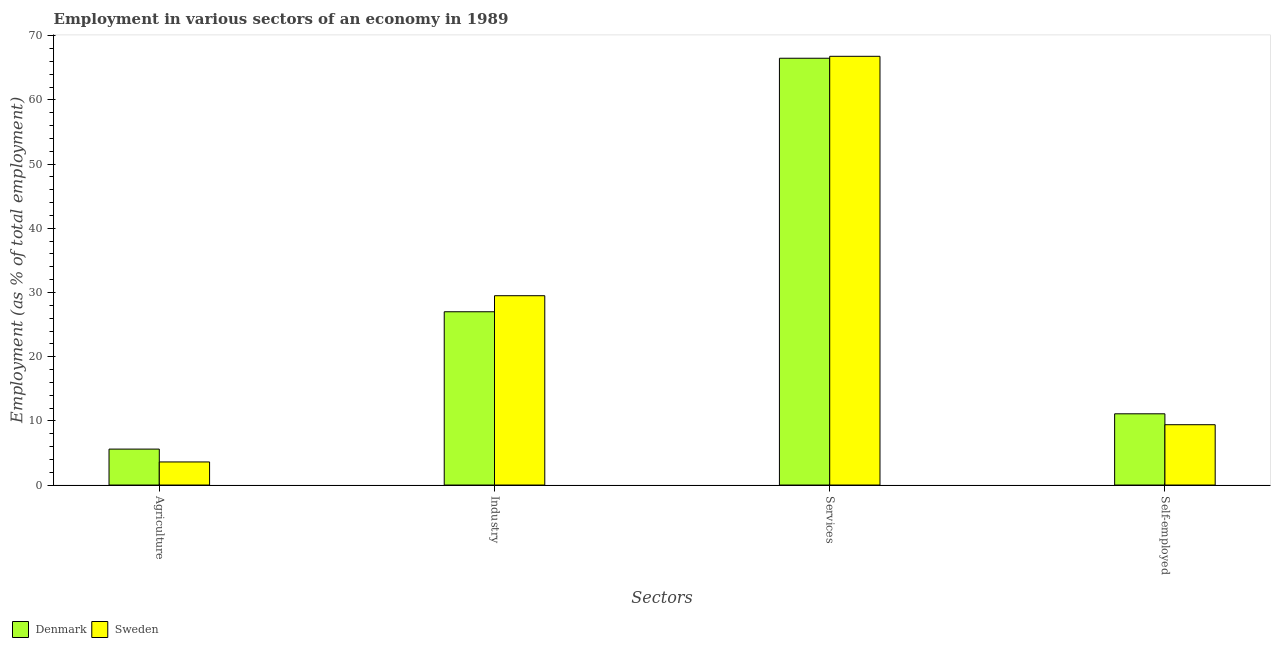Are the number of bars on each tick of the X-axis equal?
Make the answer very short. Yes. How many bars are there on the 3rd tick from the right?
Your answer should be very brief. 2. What is the label of the 2nd group of bars from the left?
Your answer should be very brief. Industry. What is the percentage of workers in services in Sweden?
Provide a succinct answer. 66.8. Across all countries, what is the maximum percentage of workers in industry?
Your answer should be compact. 29.5. In which country was the percentage of workers in industry maximum?
Your response must be concise. Sweden. What is the total percentage of workers in services in the graph?
Provide a short and direct response. 133.3. What is the difference between the percentage of workers in services in Sweden and that in Denmark?
Ensure brevity in your answer.  0.3. What is the difference between the percentage of workers in agriculture in Sweden and the percentage of workers in industry in Denmark?
Your answer should be compact. -23.4. What is the average percentage of workers in industry per country?
Give a very brief answer. 28.25. What is the difference between the percentage of workers in industry and percentage of workers in agriculture in Sweden?
Your answer should be very brief. 25.9. In how many countries, is the percentage of workers in services greater than 26 %?
Keep it short and to the point. 2. What is the ratio of the percentage of self employed workers in Denmark to that in Sweden?
Offer a very short reply. 1.18. What is the difference between the highest and the second highest percentage of self employed workers?
Provide a succinct answer. 1.7. What is the difference between the highest and the lowest percentage of workers in services?
Your response must be concise. 0.3. In how many countries, is the percentage of workers in agriculture greater than the average percentage of workers in agriculture taken over all countries?
Give a very brief answer. 1. Is it the case that in every country, the sum of the percentage of workers in agriculture and percentage of workers in industry is greater than the percentage of workers in services?
Your answer should be very brief. No. What is the difference between two consecutive major ticks on the Y-axis?
Your answer should be very brief. 10. Does the graph contain grids?
Offer a very short reply. No. What is the title of the graph?
Your answer should be very brief. Employment in various sectors of an economy in 1989. What is the label or title of the X-axis?
Ensure brevity in your answer.  Sectors. What is the label or title of the Y-axis?
Ensure brevity in your answer.  Employment (as % of total employment). What is the Employment (as % of total employment) of Denmark in Agriculture?
Your answer should be very brief. 5.6. What is the Employment (as % of total employment) of Sweden in Agriculture?
Offer a terse response. 3.6. What is the Employment (as % of total employment) of Sweden in Industry?
Offer a terse response. 29.5. What is the Employment (as % of total employment) of Denmark in Services?
Give a very brief answer. 66.5. What is the Employment (as % of total employment) of Sweden in Services?
Ensure brevity in your answer.  66.8. What is the Employment (as % of total employment) of Denmark in Self-employed?
Give a very brief answer. 11.1. What is the Employment (as % of total employment) in Sweden in Self-employed?
Your response must be concise. 9.4. Across all Sectors, what is the maximum Employment (as % of total employment) in Denmark?
Provide a succinct answer. 66.5. Across all Sectors, what is the maximum Employment (as % of total employment) in Sweden?
Ensure brevity in your answer.  66.8. Across all Sectors, what is the minimum Employment (as % of total employment) of Denmark?
Your answer should be compact. 5.6. Across all Sectors, what is the minimum Employment (as % of total employment) in Sweden?
Keep it short and to the point. 3.6. What is the total Employment (as % of total employment) in Denmark in the graph?
Offer a very short reply. 110.2. What is the total Employment (as % of total employment) of Sweden in the graph?
Ensure brevity in your answer.  109.3. What is the difference between the Employment (as % of total employment) in Denmark in Agriculture and that in Industry?
Your answer should be very brief. -21.4. What is the difference between the Employment (as % of total employment) of Sweden in Agriculture and that in Industry?
Keep it short and to the point. -25.9. What is the difference between the Employment (as % of total employment) in Denmark in Agriculture and that in Services?
Offer a terse response. -60.9. What is the difference between the Employment (as % of total employment) of Sweden in Agriculture and that in Services?
Your response must be concise. -63.2. What is the difference between the Employment (as % of total employment) in Denmark in Agriculture and that in Self-employed?
Your response must be concise. -5.5. What is the difference between the Employment (as % of total employment) in Denmark in Industry and that in Services?
Offer a very short reply. -39.5. What is the difference between the Employment (as % of total employment) of Sweden in Industry and that in Services?
Your answer should be very brief. -37.3. What is the difference between the Employment (as % of total employment) in Denmark in Industry and that in Self-employed?
Provide a short and direct response. 15.9. What is the difference between the Employment (as % of total employment) in Sweden in Industry and that in Self-employed?
Provide a short and direct response. 20.1. What is the difference between the Employment (as % of total employment) of Denmark in Services and that in Self-employed?
Your answer should be very brief. 55.4. What is the difference between the Employment (as % of total employment) in Sweden in Services and that in Self-employed?
Provide a succinct answer. 57.4. What is the difference between the Employment (as % of total employment) of Denmark in Agriculture and the Employment (as % of total employment) of Sweden in Industry?
Ensure brevity in your answer.  -23.9. What is the difference between the Employment (as % of total employment) in Denmark in Agriculture and the Employment (as % of total employment) in Sweden in Services?
Make the answer very short. -61.2. What is the difference between the Employment (as % of total employment) of Denmark in Industry and the Employment (as % of total employment) of Sweden in Services?
Provide a succinct answer. -39.8. What is the difference between the Employment (as % of total employment) in Denmark in Industry and the Employment (as % of total employment) in Sweden in Self-employed?
Keep it short and to the point. 17.6. What is the difference between the Employment (as % of total employment) in Denmark in Services and the Employment (as % of total employment) in Sweden in Self-employed?
Offer a very short reply. 57.1. What is the average Employment (as % of total employment) in Denmark per Sectors?
Keep it short and to the point. 27.55. What is the average Employment (as % of total employment) of Sweden per Sectors?
Your response must be concise. 27.32. What is the difference between the Employment (as % of total employment) of Denmark and Employment (as % of total employment) of Sweden in Agriculture?
Your answer should be very brief. 2. What is the difference between the Employment (as % of total employment) in Denmark and Employment (as % of total employment) in Sweden in Industry?
Your response must be concise. -2.5. What is the difference between the Employment (as % of total employment) of Denmark and Employment (as % of total employment) of Sweden in Services?
Provide a succinct answer. -0.3. What is the ratio of the Employment (as % of total employment) of Denmark in Agriculture to that in Industry?
Give a very brief answer. 0.21. What is the ratio of the Employment (as % of total employment) in Sweden in Agriculture to that in Industry?
Offer a terse response. 0.12. What is the ratio of the Employment (as % of total employment) in Denmark in Agriculture to that in Services?
Give a very brief answer. 0.08. What is the ratio of the Employment (as % of total employment) in Sweden in Agriculture to that in Services?
Offer a very short reply. 0.05. What is the ratio of the Employment (as % of total employment) in Denmark in Agriculture to that in Self-employed?
Your answer should be compact. 0.5. What is the ratio of the Employment (as % of total employment) in Sweden in Agriculture to that in Self-employed?
Make the answer very short. 0.38. What is the ratio of the Employment (as % of total employment) in Denmark in Industry to that in Services?
Provide a succinct answer. 0.41. What is the ratio of the Employment (as % of total employment) in Sweden in Industry to that in Services?
Offer a very short reply. 0.44. What is the ratio of the Employment (as % of total employment) of Denmark in Industry to that in Self-employed?
Your answer should be very brief. 2.43. What is the ratio of the Employment (as % of total employment) in Sweden in Industry to that in Self-employed?
Your answer should be very brief. 3.14. What is the ratio of the Employment (as % of total employment) in Denmark in Services to that in Self-employed?
Your answer should be compact. 5.99. What is the ratio of the Employment (as % of total employment) of Sweden in Services to that in Self-employed?
Your answer should be very brief. 7.11. What is the difference between the highest and the second highest Employment (as % of total employment) in Denmark?
Offer a very short reply. 39.5. What is the difference between the highest and the second highest Employment (as % of total employment) of Sweden?
Your answer should be compact. 37.3. What is the difference between the highest and the lowest Employment (as % of total employment) of Denmark?
Ensure brevity in your answer.  60.9. What is the difference between the highest and the lowest Employment (as % of total employment) in Sweden?
Provide a short and direct response. 63.2. 